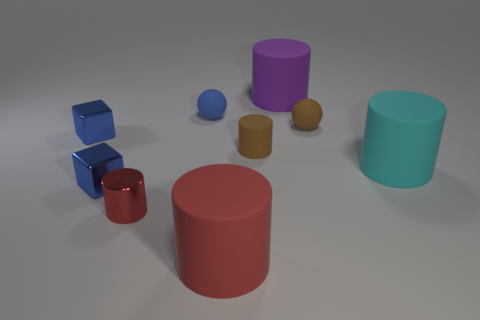Subtract 2 cylinders. How many cylinders are left? 3 Subtract all metallic cylinders. How many cylinders are left? 4 Subtract all purple cylinders. How many cylinders are left? 4 Subtract all yellow cylinders. Subtract all yellow balls. How many cylinders are left? 5 Subtract all cylinders. How many objects are left? 4 Subtract all tiny yellow cylinders. Subtract all tiny rubber spheres. How many objects are left? 7 Add 7 tiny blue things. How many tiny blue things are left? 10 Add 2 green metallic balls. How many green metallic balls exist? 2 Subtract 0 gray blocks. How many objects are left? 9 